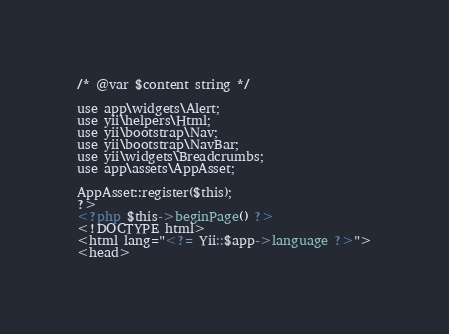<code> <loc_0><loc_0><loc_500><loc_500><_PHP_>/* @var $content string */

use app\widgets\Alert;
use yii\helpers\Html;
use yii\bootstrap\Nav;
use yii\bootstrap\NavBar;
use yii\widgets\Breadcrumbs;
use app\assets\AppAsset;

AppAsset::register($this);
?>
<?php $this->beginPage() ?>
<!DOCTYPE html>
<html lang="<?= Yii::$app->language ?>">
<head></code> 